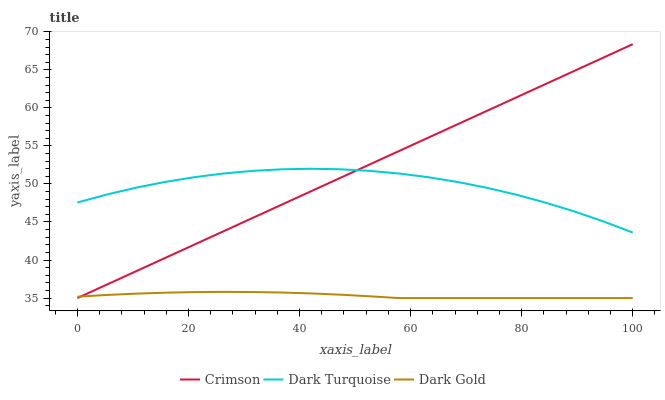Does Dark Gold have the minimum area under the curve?
Answer yes or no. Yes. Does Crimson have the maximum area under the curve?
Answer yes or no. Yes. Does Dark Turquoise have the minimum area under the curve?
Answer yes or no. No. Does Dark Turquoise have the maximum area under the curve?
Answer yes or no. No. Is Crimson the smoothest?
Answer yes or no. Yes. Is Dark Turquoise the roughest?
Answer yes or no. Yes. Is Dark Gold the smoothest?
Answer yes or no. No. Is Dark Gold the roughest?
Answer yes or no. No. Does Dark Turquoise have the lowest value?
Answer yes or no. No. Does Crimson have the highest value?
Answer yes or no. Yes. Does Dark Turquoise have the highest value?
Answer yes or no. No. Is Dark Gold less than Dark Turquoise?
Answer yes or no. Yes. Is Dark Turquoise greater than Dark Gold?
Answer yes or no. Yes. Does Dark Gold intersect Crimson?
Answer yes or no. Yes. Is Dark Gold less than Crimson?
Answer yes or no. No. Is Dark Gold greater than Crimson?
Answer yes or no. No. Does Dark Gold intersect Dark Turquoise?
Answer yes or no. No. 